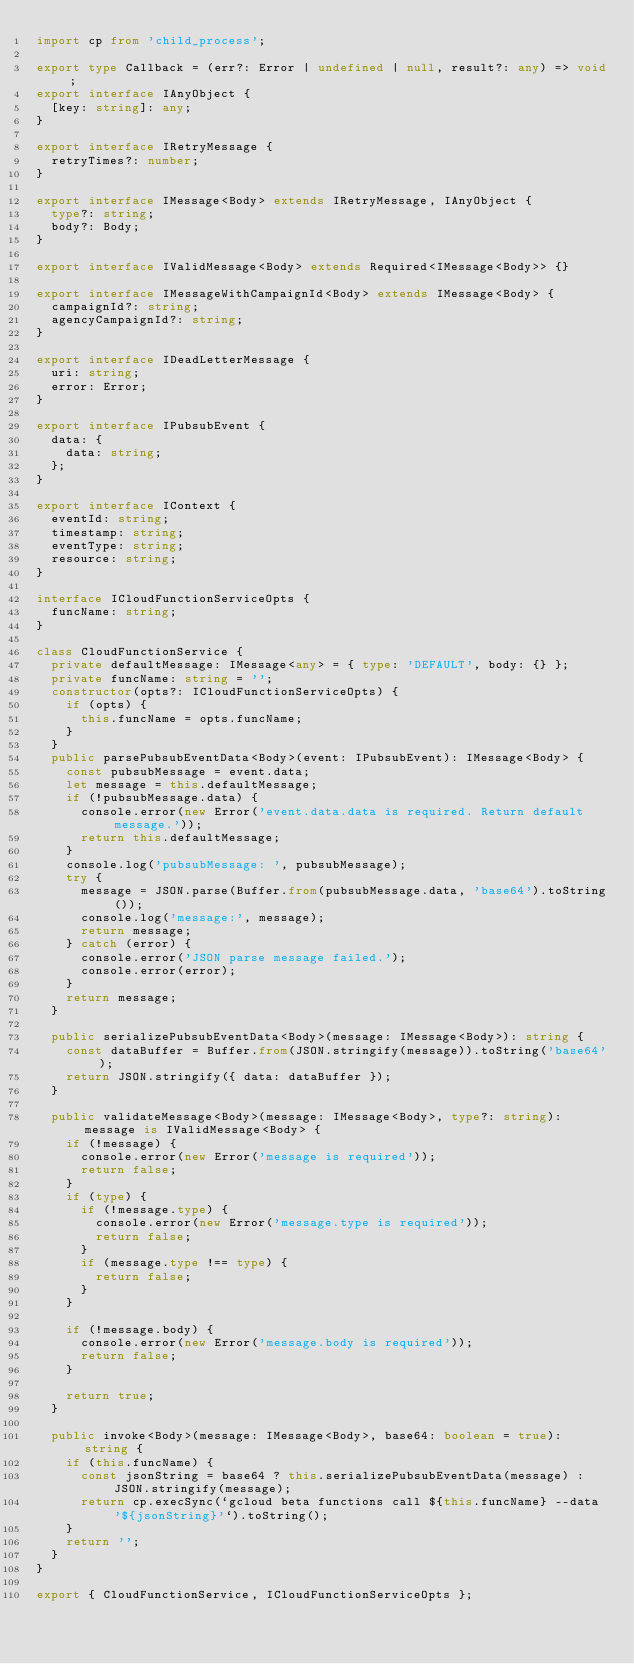Convert code to text. <code><loc_0><loc_0><loc_500><loc_500><_TypeScript_>import cp from 'child_process';

export type Callback = (err?: Error | undefined | null, result?: any) => void;
export interface IAnyObject {
  [key: string]: any;
}

export interface IRetryMessage {
  retryTimes?: number;
}

export interface IMessage<Body> extends IRetryMessage, IAnyObject {
  type?: string;
  body?: Body;
}

export interface IValidMessage<Body> extends Required<IMessage<Body>> {}

export interface IMessageWithCampaignId<Body> extends IMessage<Body> {
  campaignId?: string;
  agencyCampaignId?: string;
}

export interface IDeadLetterMessage {
  uri: string;
  error: Error;
}

export interface IPubsubEvent {
  data: {
    data: string;
  };
}

export interface IContext {
  eventId: string;
  timestamp: string;
  eventType: string;
  resource: string;
}

interface ICloudFunctionServiceOpts {
  funcName: string;
}

class CloudFunctionService {
  private defaultMessage: IMessage<any> = { type: 'DEFAULT', body: {} };
  private funcName: string = '';
  constructor(opts?: ICloudFunctionServiceOpts) {
    if (opts) {
      this.funcName = opts.funcName;
    }
  }
  public parsePubsubEventData<Body>(event: IPubsubEvent): IMessage<Body> {
    const pubsubMessage = event.data;
    let message = this.defaultMessage;
    if (!pubsubMessage.data) {
      console.error(new Error('event.data.data is required. Return default message.'));
      return this.defaultMessage;
    }
    console.log('pubsubMessage: ', pubsubMessage);
    try {
      message = JSON.parse(Buffer.from(pubsubMessage.data, 'base64').toString());
      console.log('message:', message);
      return message;
    } catch (error) {
      console.error('JSON parse message failed.');
      console.error(error);
    }
    return message;
  }

  public serializePubsubEventData<Body>(message: IMessage<Body>): string {
    const dataBuffer = Buffer.from(JSON.stringify(message)).toString('base64');
    return JSON.stringify({ data: dataBuffer });
  }

  public validateMessage<Body>(message: IMessage<Body>, type?: string): message is IValidMessage<Body> {
    if (!message) {
      console.error(new Error('message is required'));
      return false;
    }
    if (type) {
      if (!message.type) {
        console.error(new Error('message.type is required'));
        return false;
      }
      if (message.type !== type) {
        return false;
      }
    }

    if (!message.body) {
      console.error(new Error('message.body is required'));
      return false;
    }

    return true;
  }

  public invoke<Body>(message: IMessage<Body>, base64: boolean = true): string {
    if (this.funcName) {
      const jsonString = base64 ? this.serializePubsubEventData(message) : JSON.stringify(message);
      return cp.execSync(`gcloud beta functions call ${this.funcName} --data '${jsonString}'`).toString();
    }
    return '';
  }
}

export { CloudFunctionService, ICloudFunctionServiceOpts };
</code> 